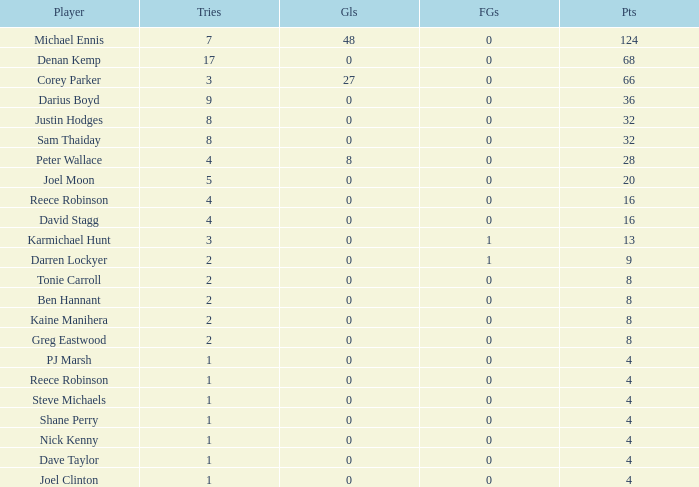What is the total number of field goals of Denan Kemp, who has more than 4 tries, more than 32 points, and 0 goals? 1.0. 